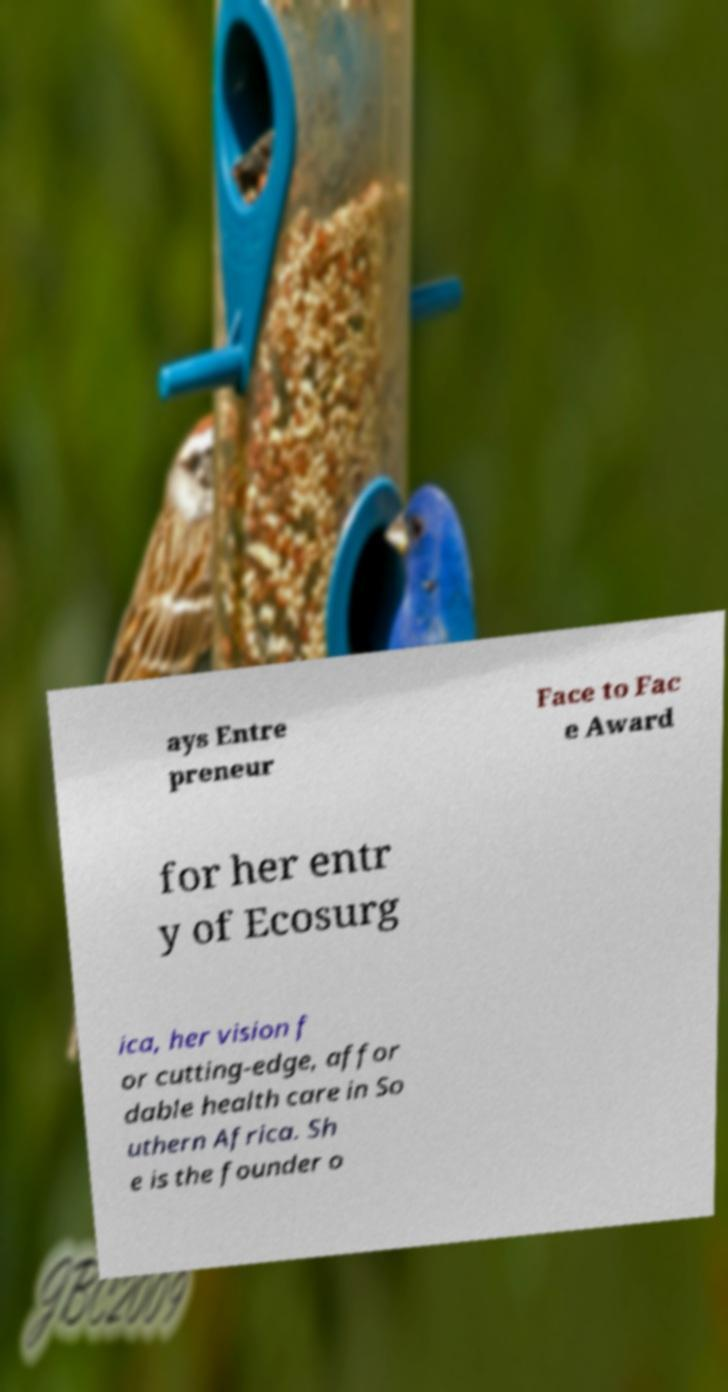For documentation purposes, I need the text within this image transcribed. Could you provide that? ays Entre preneur Face to Fac e Award for her entr y of Ecosurg ica, her vision f or cutting-edge, affor dable health care in So uthern Africa. Sh e is the founder o 